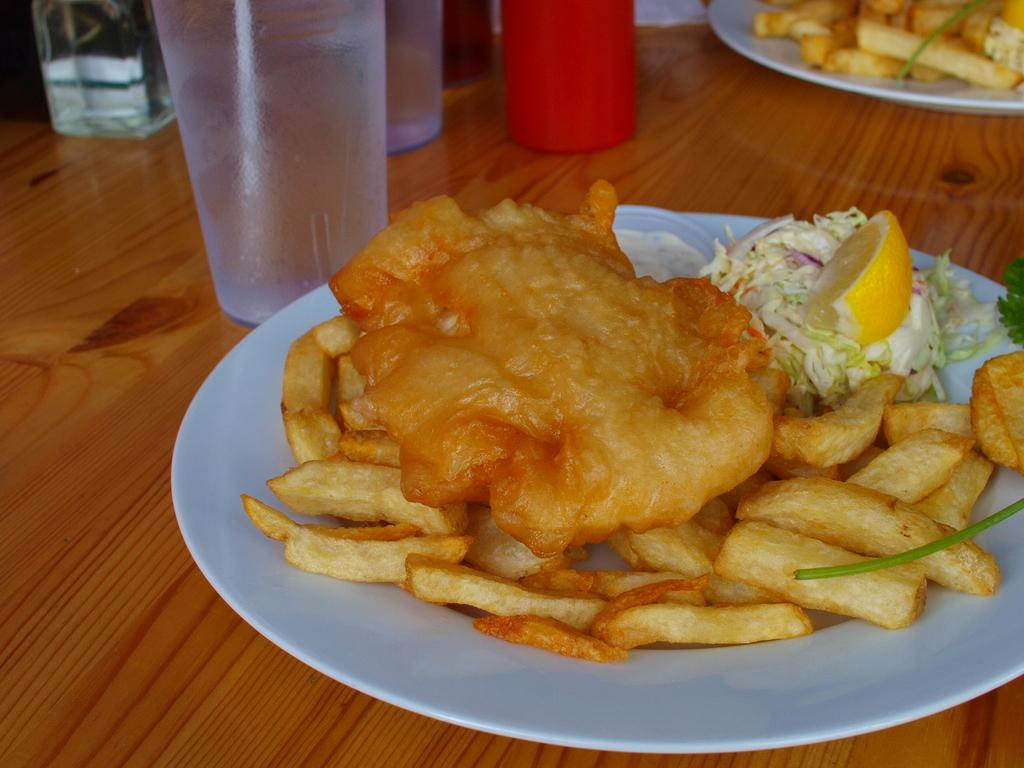What is on the plates that are visible in the image? There are food items on plates in the image. Where are the plates with food items located? The plates are placed on a table. What else can be seen on the table in the image? There are glasses on the table in the image. How many roofs can be seen in the image? There is no roof visible in the image; it only shows food items on plates, plates on a table, and glasses on the table. Is there a duck swimming in the food on the plates? There is no duck present in the image; it only shows food items on plates, plates on a table, and glasses on the table. 